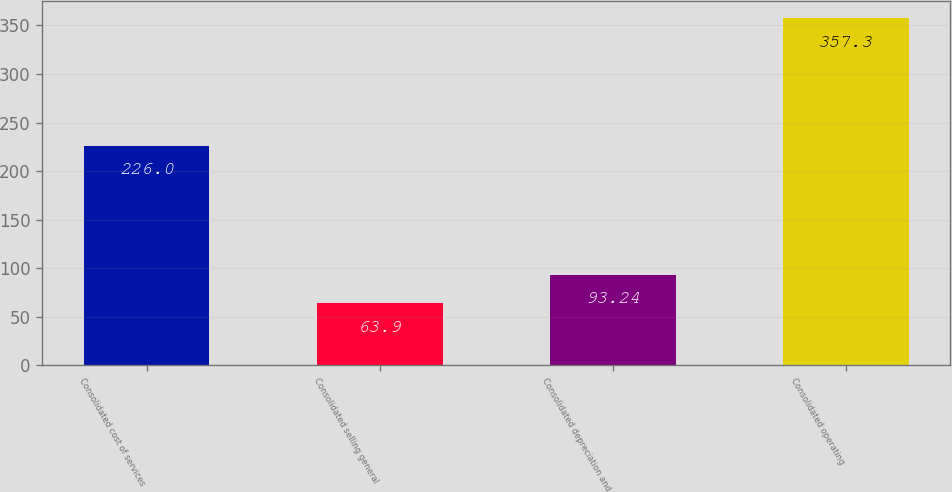Convert chart to OTSL. <chart><loc_0><loc_0><loc_500><loc_500><bar_chart><fcel>Consolidated cost of services<fcel>Consolidated selling general<fcel>Consolidated depreciation and<fcel>Consolidated operating<nl><fcel>226<fcel>63.9<fcel>93.24<fcel>357.3<nl></chart> 